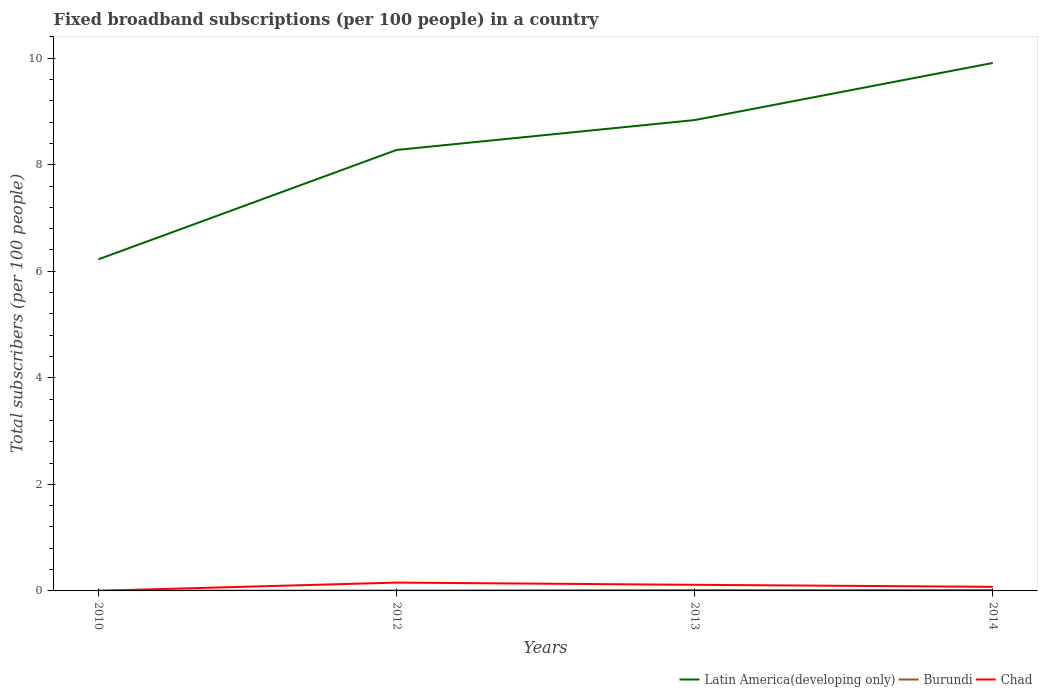How many different coloured lines are there?
Ensure brevity in your answer.  3. Is the number of lines equal to the number of legend labels?
Give a very brief answer. Yes. Across all years, what is the maximum number of broadband subscriptions in Latin America(developing only)?
Offer a terse response. 6.22. What is the total number of broadband subscriptions in Chad in the graph?
Make the answer very short. -0.15. What is the difference between the highest and the second highest number of broadband subscriptions in Chad?
Keep it short and to the point. 0.15. What is the difference between the highest and the lowest number of broadband subscriptions in Latin America(developing only)?
Your answer should be very brief. 2. Is the number of broadband subscriptions in Chad strictly greater than the number of broadband subscriptions in Burundi over the years?
Provide a short and direct response. No. Are the values on the major ticks of Y-axis written in scientific E-notation?
Keep it short and to the point. No. What is the title of the graph?
Offer a terse response. Fixed broadband subscriptions (per 100 people) in a country. Does "Puerto Rico" appear as one of the legend labels in the graph?
Provide a succinct answer. No. What is the label or title of the X-axis?
Provide a short and direct response. Years. What is the label or title of the Y-axis?
Your answer should be very brief. Total subscribers (per 100 people). What is the Total subscribers (per 100 people) of Latin America(developing only) in 2010?
Offer a very short reply. 6.22. What is the Total subscribers (per 100 people) in Burundi in 2010?
Offer a terse response. 0. What is the Total subscribers (per 100 people) in Chad in 2010?
Give a very brief answer. 0. What is the Total subscribers (per 100 people) in Latin America(developing only) in 2012?
Your answer should be very brief. 8.28. What is the Total subscribers (per 100 people) in Burundi in 2012?
Give a very brief answer. 0.01. What is the Total subscribers (per 100 people) of Chad in 2012?
Give a very brief answer. 0.16. What is the Total subscribers (per 100 people) of Latin America(developing only) in 2013?
Keep it short and to the point. 8.84. What is the Total subscribers (per 100 people) in Burundi in 2013?
Offer a very short reply. 0.02. What is the Total subscribers (per 100 people) in Chad in 2013?
Give a very brief answer. 0.11. What is the Total subscribers (per 100 people) in Latin America(developing only) in 2014?
Keep it short and to the point. 9.91. What is the Total subscribers (per 100 people) in Burundi in 2014?
Make the answer very short. 0.02. What is the Total subscribers (per 100 people) of Chad in 2014?
Keep it short and to the point. 0.08. Across all years, what is the maximum Total subscribers (per 100 people) in Latin America(developing only)?
Make the answer very short. 9.91. Across all years, what is the maximum Total subscribers (per 100 people) in Burundi?
Offer a terse response. 0.02. Across all years, what is the maximum Total subscribers (per 100 people) of Chad?
Your answer should be compact. 0.16. Across all years, what is the minimum Total subscribers (per 100 people) in Latin America(developing only)?
Give a very brief answer. 6.22. Across all years, what is the minimum Total subscribers (per 100 people) of Burundi?
Keep it short and to the point. 0. Across all years, what is the minimum Total subscribers (per 100 people) of Chad?
Your answer should be very brief. 0. What is the total Total subscribers (per 100 people) in Latin America(developing only) in the graph?
Provide a short and direct response. 33.25. What is the total Total subscribers (per 100 people) of Burundi in the graph?
Provide a short and direct response. 0.04. What is the total Total subscribers (per 100 people) in Chad in the graph?
Provide a succinct answer. 0.35. What is the difference between the Total subscribers (per 100 people) in Latin America(developing only) in 2010 and that in 2012?
Your answer should be compact. -2.05. What is the difference between the Total subscribers (per 100 people) of Burundi in 2010 and that in 2012?
Make the answer very short. -0. What is the difference between the Total subscribers (per 100 people) of Chad in 2010 and that in 2012?
Your response must be concise. -0.15. What is the difference between the Total subscribers (per 100 people) of Latin America(developing only) in 2010 and that in 2013?
Give a very brief answer. -2.61. What is the difference between the Total subscribers (per 100 people) in Burundi in 2010 and that in 2013?
Keep it short and to the point. -0.01. What is the difference between the Total subscribers (per 100 people) of Chad in 2010 and that in 2013?
Your response must be concise. -0.11. What is the difference between the Total subscribers (per 100 people) of Latin America(developing only) in 2010 and that in 2014?
Your answer should be compact. -3.69. What is the difference between the Total subscribers (per 100 people) of Burundi in 2010 and that in 2014?
Give a very brief answer. -0.01. What is the difference between the Total subscribers (per 100 people) of Chad in 2010 and that in 2014?
Your answer should be compact. -0.07. What is the difference between the Total subscribers (per 100 people) of Latin America(developing only) in 2012 and that in 2013?
Ensure brevity in your answer.  -0.56. What is the difference between the Total subscribers (per 100 people) of Burundi in 2012 and that in 2013?
Keep it short and to the point. -0.01. What is the difference between the Total subscribers (per 100 people) of Chad in 2012 and that in 2013?
Offer a terse response. 0.04. What is the difference between the Total subscribers (per 100 people) of Latin America(developing only) in 2012 and that in 2014?
Offer a very short reply. -1.63. What is the difference between the Total subscribers (per 100 people) of Burundi in 2012 and that in 2014?
Keep it short and to the point. -0.01. What is the difference between the Total subscribers (per 100 people) of Chad in 2012 and that in 2014?
Your answer should be very brief. 0.08. What is the difference between the Total subscribers (per 100 people) of Latin America(developing only) in 2013 and that in 2014?
Provide a short and direct response. -1.07. What is the difference between the Total subscribers (per 100 people) in Burundi in 2013 and that in 2014?
Provide a succinct answer. -0. What is the difference between the Total subscribers (per 100 people) of Chad in 2013 and that in 2014?
Your answer should be very brief. 0.04. What is the difference between the Total subscribers (per 100 people) in Latin America(developing only) in 2010 and the Total subscribers (per 100 people) in Burundi in 2012?
Ensure brevity in your answer.  6.22. What is the difference between the Total subscribers (per 100 people) of Latin America(developing only) in 2010 and the Total subscribers (per 100 people) of Chad in 2012?
Your answer should be very brief. 6.07. What is the difference between the Total subscribers (per 100 people) of Burundi in 2010 and the Total subscribers (per 100 people) of Chad in 2012?
Make the answer very short. -0.15. What is the difference between the Total subscribers (per 100 people) of Latin America(developing only) in 2010 and the Total subscribers (per 100 people) of Burundi in 2013?
Your response must be concise. 6.21. What is the difference between the Total subscribers (per 100 people) in Latin America(developing only) in 2010 and the Total subscribers (per 100 people) in Chad in 2013?
Offer a terse response. 6.11. What is the difference between the Total subscribers (per 100 people) in Burundi in 2010 and the Total subscribers (per 100 people) in Chad in 2013?
Your response must be concise. -0.11. What is the difference between the Total subscribers (per 100 people) of Latin America(developing only) in 2010 and the Total subscribers (per 100 people) of Burundi in 2014?
Keep it short and to the point. 6.21. What is the difference between the Total subscribers (per 100 people) of Latin America(developing only) in 2010 and the Total subscribers (per 100 people) of Chad in 2014?
Your response must be concise. 6.15. What is the difference between the Total subscribers (per 100 people) of Burundi in 2010 and the Total subscribers (per 100 people) of Chad in 2014?
Offer a very short reply. -0.07. What is the difference between the Total subscribers (per 100 people) of Latin America(developing only) in 2012 and the Total subscribers (per 100 people) of Burundi in 2013?
Provide a succinct answer. 8.26. What is the difference between the Total subscribers (per 100 people) in Latin America(developing only) in 2012 and the Total subscribers (per 100 people) in Chad in 2013?
Give a very brief answer. 8.16. What is the difference between the Total subscribers (per 100 people) in Burundi in 2012 and the Total subscribers (per 100 people) in Chad in 2013?
Your answer should be compact. -0.11. What is the difference between the Total subscribers (per 100 people) in Latin America(developing only) in 2012 and the Total subscribers (per 100 people) in Burundi in 2014?
Make the answer very short. 8.26. What is the difference between the Total subscribers (per 100 people) of Latin America(developing only) in 2012 and the Total subscribers (per 100 people) of Chad in 2014?
Offer a terse response. 8.2. What is the difference between the Total subscribers (per 100 people) of Burundi in 2012 and the Total subscribers (per 100 people) of Chad in 2014?
Your response must be concise. -0.07. What is the difference between the Total subscribers (per 100 people) in Latin America(developing only) in 2013 and the Total subscribers (per 100 people) in Burundi in 2014?
Provide a succinct answer. 8.82. What is the difference between the Total subscribers (per 100 people) of Latin America(developing only) in 2013 and the Total subscribers (per 100 people) of Chad in 2014?
Your response must be concise. 8.76. What is the difference between the Total subscribers (per 100 people) of Burundi in 2013 and the Total subscribers (per 100 people) of Chad in 2014?
Ensure brevity in your answer.  -0.06. What is the average Total subscribers (per 100 people) of Latin America(developing only) per year?
Offer a very short reply. 8.31. What is the average Total subscribers (per 100 people) in Burundi per year?
Your response must be concise. 0.01. What is the average Total subscribers (per 100 people) in Chad per year?
Give a very brief answer. 0.09. In the year 2010, what is the difference between the Total subscribers (per 100 people) of Latin America(developing only) and Total subscribers (per 100 people) of Burundi?
Keep it short and to the point. 6.22. In the year 2010, what is the difference between the Total subscribers (per 100 people) of Latin America(developing only) and Total subscribers (per 100 people) of Chad?
Provide a succinct answer. 6.22. In the year 2010, what is the difference between the Total subscribers (per 100 people) of Burundi and Total subscribers (per 100 people) of Chad?
Your answer should be very brief. 0. In the year 2012, what is the difference between the Total subscribers (per 100 people) in Latin America(developing only) and Total subscribers (per 100 people) in Burundi?
Make the answer very short. 8.27. In the year 2012, what is the difference between the Total subscribers (per 100 people) of Latin America(developing only) and Total subscribers (per 100 people) of Chad?
Your answer should be compact. 8.12. In the year 2012, what is the difference between the Total subscribers (per 100 people) of Burundi and Total subscribers (per 100 people) of Chad?
Your answer should be compact. -0.15. In the year 2013, what is the difference between the Total subscribers (per 100 people) of Latin America(developing only) and Total subscribers (per 100 people) of Burundi?
Give a very brief answer. 8.82. In the year 2013, what is the difference between the Total subscribers (per 100 people) in Latin America(developing only) and Total subscribers (per 100 people) in Chad?
Make the answer very short. 8.72. In the year 2013, what is the difference between the Total subscribers (per 100 people) in Burundi and Total subscribers (per 100 people) in Chad?
Offer a very short reply. -0.1. In the year 2014, what is the difference between the Total subscribers (per 100 people) in Latin America(developing only) and Total subscribers (per 100 people) in Burundi?
Keep it short and to the point. 9.89. In the year 2014, what is the difference between the Total subscribers (per 100 people) of Latin America(developing only) and Total subscribers (per 100 people) of Chad?
Offer a terse response. 9.83. In the year 2014, what is the difference between the Total subscribers (per 100 people) of Burundi and Total subscribers (per 100 people) of Chad?
Your answer should be very brief. -0.06. What is the ratio of the Total subscribers (per 100 people) of Latin America(developing only) in 2010 to that in 2012?
Ensure brevity in your answer.  0.75. What is the ratio of the Total subscribers (per 100 people) of Burundi in 2010 to that in 2012?
Your answer should be compact. 0.53. What is the ratio of the Total subscribers (per 100 people) of Chad in 2010 to that in 2012?
Ensure brevity in your answer.  0.02. What is the ratio of the Total subscribers (per 100 people) in Latin America(developing only) in 2010 to that in 2013?
Ensure brevity in your answer.  0.7. What is the ratio of the Total subscribers (per 100 people) in Burundi in 2010 to that in 2013?
Provide a short and direct response. 0.25. What is the ratio of the Total subscribers (per 100 people) of Chad in 2010 to that in 2013?
Your response must be concise. 0.02. What is the ratio of the Total subscribers (per 100 people) in Latin America(developing only) in 2010 to that in 2014?
Provide a short and direct response. 0.63. What is the ratio of the Total subscribers (per 100 people) in Burundi in 2010 to that in 2014?
Keep it short and to the point. 0.24. What is the ratio of the Total subscribers (per 100 people) in Chad in 2010 to that in 2014?
Provide a succinct answer. 0.04. What is the ratio of the Total subscribers (per 100 people) of Latin America(developing only) in 2012 to that in 2013?
Provide a short and direct response. 0.94. What is the ratio of the Total subscribers (per 100 people) of Burundi in 2012 to that in 2013?
Provide a succinct answer. 0.47. What is the ratio of the Total subscribers (per 100 people) of Chad in 2012 to that in 2013?
Give a very brief answer. 1.36. What is the ratio of the Total subscribers (per 100 people) in Latin America(developing only) in 2012 to that in 2014?
Your response must be concise. 0.84. What is the ratio of the Total subscribers (per 100 people) in Burundi in 2012 to that in 2014?
Keep it short and to the point. 0.44. What is the ratio of the Total subscribers (per 100 people) in Chad in 2012 to that in 2014?
Provide a succinct answer. 2.04. What is the ratio of the Total subscribers (per 100 people) of Latin America(developing only) in 2013 to that in 2014?
Make the answer very short. 0.89. What is the ratio of the Total subscribers (per 100 people) in Burundi in 2013 to that in 2014?
Your answer should be very brief. 0.93. What is the ratio of the Total subscribers (per 100 people) of Chad in 2013 to that in 2014?
Your response must be concise. 1.49. What is the difference between the highest and the second highest Total subscribers (per 100 people) of Latin America(developing only)?
Provide a succinct answer. 1.07. What is the difference between the highest and the second highest Total subscribers (per 100 people) in Burundi?
Offer a very short reply. 0. What is the difference between the highest and the second highest Total subscribers (per 100 people) in Chad?
Offer a terse response. 0.04. What is the difference between the highest and the lowest Total subscribers (per 100 people) of Latin America(developing only)?
Your response must be concise. 3.69. What is the difference between the highest and the lowest Total subscribers (per 100 people) of Burundi?
Ensure brevity in your answer.  0.01. What is the difference between the highest and the lowest Total subscribers (per 100 people) in Chad?
Your answer should be very brief. 0.15. 